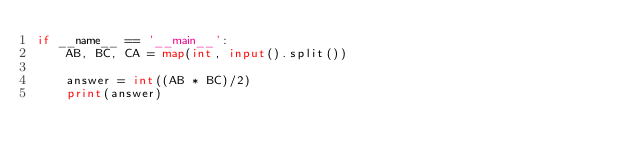<code> <loc_0><loc_0><loc_500><loc_500><_Python_>if __name__ == '__main__':
    AB, BC, CA = map(int, input().split())

    answer = int((AB * BC)/2)
    print(answer)
</code> 